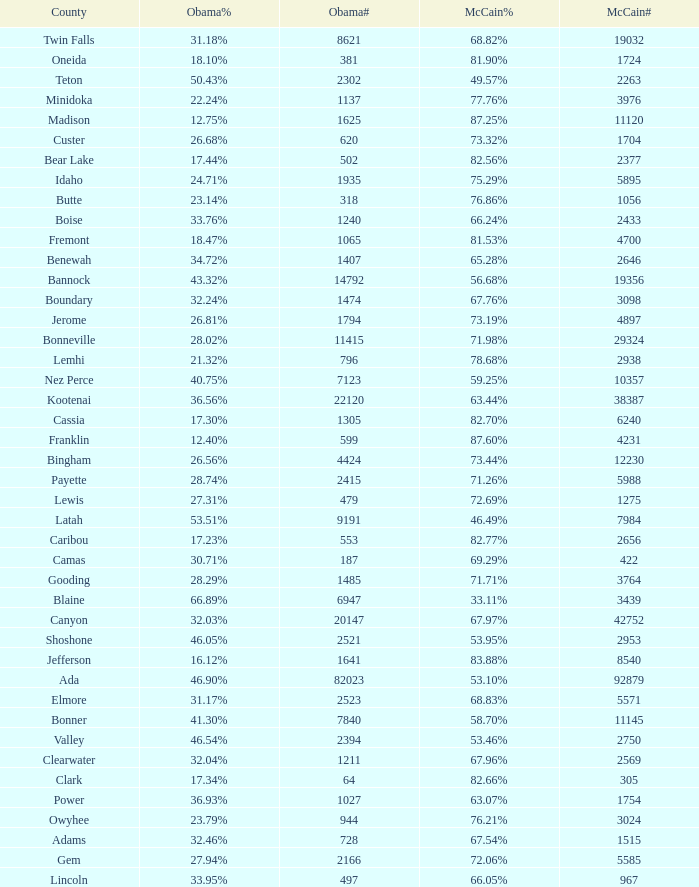Could you help me parse every detail presented in this table? {'header': ['County', 'Obama%', 'Obama#', 'McCain%', 'McCain#'], 'rows': [['Twin Falls', '31.18%', '8621', '68.82%', '19032'], ['Oneida', '18.10%', '381', '81.90%', '1724'], ['Teton', '50.43%', '2302', '49.57%', '2263'], ['Minidoka', '22.24%', '1137', '77.76%', '3976'], ['Madison', '12.75%', '1625', '87.25%', '11120'], ['Custer', '26.68%', '620', '73.32%', '1704'], ['Bear Lake', '17.44%', '502', '82.56%', '2377'], ['Idaho', '24.71%', '1935', '75.29%', '5895'], ['Butte', '23.14%', '318', '76.86%', '1056'], ['Boise', '33.76%', '1240', '66.24%', '2433'], ['Fremont', '18.47%', '1065', '81.53%', '4700'], ['Benewah', '34.72%', '1407', '65.28%', '2646'], ['Bannock', '43.32%', '14792', '56.68%', '19356'], ['Boundary', '32.24%', '1474', '67.76%', '3098'], ['Jerome', '26.81%', '1794', '73.19%', '4897'], ['Bonneville', '28.02%', '11415', '71.98%', '29324'], ['Lemhi', '21.32%', '796', '78.68%', '2938'], ['Nez Perce', '40.75%', '7123', '59.25%', '10357'], ['Kootenai', '36.56%', '22120', '63.44%', '38387'], ['Cassia', '17.30%', '1305', '82.70%', '6240'], ['Franklin', '12.40%', '599', '87.60%', '4231'], ['Bingham', '26.56%', '4424', '73.44%', '12230'], ['Payette', '28.74%', '2415', '71.26%', '5988'], ['Lewis', '27.31%', '479', '72.69%', '1275'], ['Latah', '53.51%', '9191', '46.49%', '7984'], ['Caribou', '17.23%', '553', '82.77%', '2656'], ['Camas', '30.71%', '187', '69.29%', '422'], ['Gooding', '28.29%', '1485', '71.71%', '3764'], ['Blaine', '66.89%', '6947', '33.11%', '3439'], ['Canyon', '32.03%', '20147', '67.97%', '42752'], ['Shoshone', '46.05%', '2521', '53.95%', '2953'], ['Jefferson', '16.12%', '1641', '83.88%', '8540'], ['Ada', '46.90%', '82023', '53.10%', '92879'], ['Elmore', '31.17%', '2523', '68.83%', '5571'], ['Bonner', '41.30%', '7840', '58.70%', '11145'], ['Valley', '46.54%', '2394', '53.46%', '2750'], ['Clearwater', '32.04%', '1211', '67.96%', '2569'], ['Clark', '17.34%', '64', '82.66%', '305'], ['Power', '36.93%', '1027', '63.07%', '1754'], ['Owyhee', '23.79%', '944', '76.21%', '3024'], ['Adams', '32.46%', '728', '67.54%', '1515'], ['Gem', '27.94%', '2166', '72.06%', '5585'], ['Lincoln', '33.95%', '497', '66.05%', '967']]} What is the McCain vote percentage in Jerome county? 73.19%. 